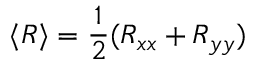Convert formula to latex. <formula><loc_0><loc_0><loc_500><loc_500>\langle R \rangle = \frac { 1 } { 2 } ( R _ { x x } + R _ { y y } )</formula> 